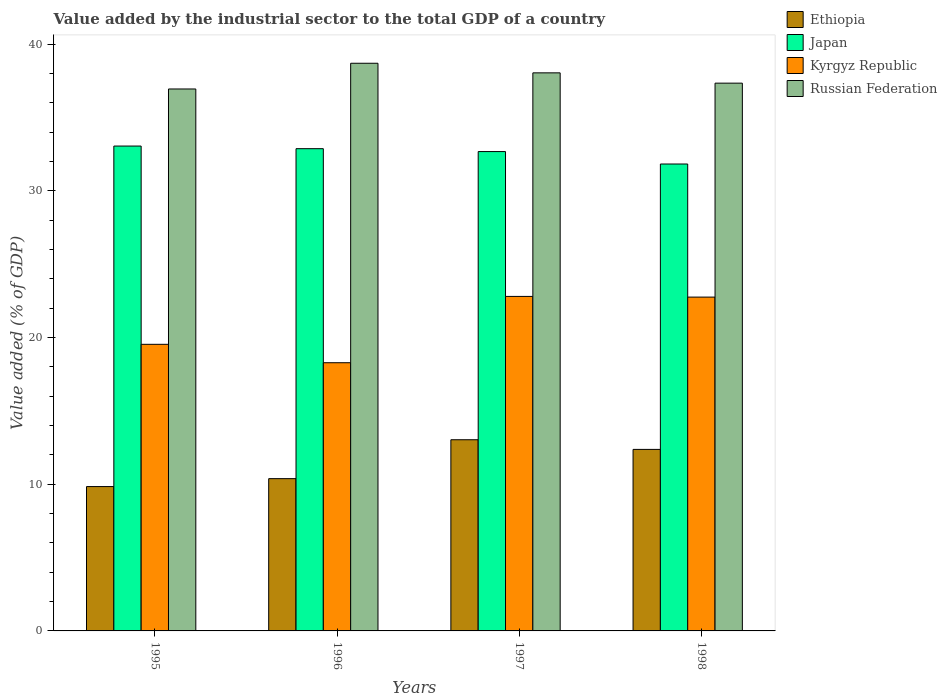How many groups of bars are there?
Ensure brevity in your answer.  4. Are the number of bars per tick equal to the number of legend labels?
Keep it short and to the point. Yes. How many bars are there on the 3rd tick from the left?
Your answer should be very brief. 4. How many bars are there on the 4th tick from the right?
Your answer should be compact. 4. What is the label of the 1st group of bars from the left?
Keep it short and to the point. 1995. In how many cases, is the number of bars for a given year not equal to the number of legend labels?
Give a very brief answer. 0. What is the value added by the industrial sector to the total GDP in Russian Federation in 1998?
Provide a succinct answer. 37.35. Across all years, what is the maximum value added by the industrial sector to the total GDP in Kyrgyz Republic?
Your answer should be very brief. 22.81. Across all years, what is the minimum value added by the industrial sector to the total GDP in Ethiopia?
Your answer should be very brief. 9.84. What is the total value added by the industrial sector to the total GDP in Japan in the graph?
Give a very brief answer. 130.48. What is the difference between the value added by the industrial sector to the total GDP in Kyrgyz Republic in 1995 and that in 1997?
Your response must be concise. -3.27. What is the difference between the value added by the industrial sector to the total GDP in Kyrgyz Republic in 1997 and the value added by the industrial sector to the total GDP in Japan in 1995?
Offer a terse response. -10.25. What is the average value added by the industrial sector to the total GDP in Ethiopia per year?
Provide a succinct answer. 11.41. In the year 1995, what is the difference between the value added by the industrial sector to the total GDP in Russian Federation and value added by the industrial sector to the total GDP in Ethiopia?
Ensure brevity in your answer.  27.11. What is the ratio of the value added by the industrial sector to the total GDP in Kyrgyz Republic in 1995 to that in 1997?
Provide a succinct answer. 0.86. Is the value added by the industrial sector to the total GDP in Russian Federation in 1996 less than that in 1998?
Give a very brief answer. No. What is the difference between the highest and the second highest value added by the industrial sector to the total GDP in Ethiopia?
Give a very brief answer. 0.66. What is the difference between the highest and the lowest value added by the industrial sector to the total GDP in Japan?
Give a very brief answer. 1.22. In how many years, is the value added by the industrial sector to the total GDP in Kyrgyz Republic greater than the average value added by the industrial sector to the total GDP in Kyrgyz Republic taken over all years?
Your response must be concise. 2. What does the 4th bar from the left in 1997 represents?
Your response must be concise. Russian Federation. What does the 1st bar from the right in 1995 represents?
Your answer should be very brief. Russian Federation. How many bars are there?
Keep it short and to the point. 16. How many years are there in the graph?
Provide a short and direct response. 4. Are the values on the major ticks of Y-axis written in scientific E-notation?
Make the answer very short. No. Where does the legend appear in the graph?
Your answer should be very brief. Top right. How many legend labels are there?
Keep it short and to the point. 4. What is the title of the graph?
Make the answer very short. Value added by the industrial sector to the total GDP of a country. What is the label or title of the X-axis?
Keep it short and to the point. Years. What is the label or title of the Y-axis?
Provide a short and direct response. Value added (% of GDP). What is the Value added (% of GDP) of Ethiopia in 1995?
Ensure brevity in your answer.  9.84. What is the Value added (% of GDP) of Japan in 1995?
Keep it short and to the point. 33.06. What is the Value added (% of GDP) in Kyrgyz Republic in 1995?
Offer a very short reply. 19.54. What is the Value added (% of GDP) of Russian Federation in 1995?
Offer a very short reply. 36.96. What is the Value added (% of GDP) of Ethiopia in 1996?
Give a very brief answer. 10.38. What is the Value added (% of GDP) in Japan in 1996?
Ensure brevity in your answer.  32.88. What is the Value added (% of GDP) of Kyrgyz Republic in 1996?
Your answer should be very brief. 18.29. What is the Value added (% of GDP) in Russian Federation in 1996?
Offer a very short reply. 38.71. What is the Value added (% of GDP) of Ethiopia in 1997?
Ensure brevity in your answer.  13.04. What is the Value added (% of GDP) in Japan in 1997?
Offer a very short reply. 32.69. What is the Value added (% of GDP) in Kyrgyz Republic in 1997?
Provide a short and direct response. 22.81. What is the Value added (% of GDP) of Russian Federation in 1997?
Offer a terse response. 38.06. What is the Value added (% of GDP) of Ethiopia in 1998?
Ensure brevity in your answer.  12.38. What is the Value added (% of GDP) in Japan in 1998?
Offer a terse response. 31.84. What is the Value added (% of GDP) of Kyrgyz Republic in 1998?
Make the answer very short. 22.76. What is the Value added (% of GDP) in Russian Federation in 1998?
Offer a very short reply. 37.35. Across all years, what is the maximum Value added (% of GDP) of Ethiopia?
Make the answer very short. 13.04. Across all years, what is the maximum Value added (% of GDP) in Japan?
Keep it short and to the point. 33.06. Across all years, what is the maximum Value added (% of GDP) of Kyrgyz Republic?
Make the answer very short. 22.81. Across all years, what is the maximum Value added (% of GDP) in Russian Federation?
Your answer should be very brief. 38.71. Across all years, what is the minimum Value added (% of GDP) of Ethiopia?
Your response must be concise. 9.84. Across all years, what is the minimum Value added (% of GDP) in Japan?
Offer a very short reply. 31.84. Across all years, what is the minimum Value added (% of GDP) of Kyrgyz Republic?
Provide a succinct answer. 18.29. Across all years, what is the minimum Value added (% of GDP) of Russian Federation?
Ensure brevity in your answer.  36.96. What is the total Value added (% of GDP) of Ethiopia in the graph?
Provide a short and direct response. 45.64. What is the total Value added (% of GDP) of Japan in the graph?
Your response must be concise. 130.48. What is the total Value added (% of GDP) of Kyrgyz Republic in the graph?
Your answer should be very brief. 83.41. What is the total Value added (% of GDP) in Russian Federation in the graph?
Offer a terse response. 151.07. What is the difference between the Value added (% of GDP) in Ethiopia in 1995 and that in 1996?
Provide a short and direct response. -0.54. What is the difference between the Value added (% of GDP) of Japan in 1995 and that in 1996?
Make the answer very short. 0.18. What is the difference between the Value added (% of GDP) of Kyrgyz Republic in 1995 and that in 1996?
Give a very brief answer. 1.25. What is the difference between the Value added (% of GDP) of Russian Federation in 1995 and that in 1996?
Make the answer very short. -1.75. What is the difference between the Value added (% of GDP) of Ethiopia in 1995 and that in 1997?
Make the answer very short. -3.19. What is the difference between the Value added (% of GDP) of Japan in 1995 and that in 1997?
Provide a short and direct response. 0.38. What is the difference between the Value added (% of GDP) of Kyrgyz Republic in 1995 and that in 1997?
Keep it short and to the point. -3.27. What is the difference between the Value added (% of GDP) in Russian Federation in 1995 and that in 1997?
Offer a terse response. -1.1. What is the difference between the Value added (% of GDP) in Ethiopia in 1995 and that in 1998?
Give a very brief answer. -2.54. What is the difference between the Value added (% of GDP) of Japan in 1995 and that in 1998?
Provide a succinct answer. 1.22. What is the difference between the Value added (% of GDP) in Kyrgyz Republic in 1995 and that in 1998?
Your response must be concise. -3.22. What is the difference between the Value added (% of GDP) in Russian Federation in 1995 and that in 1998?
Your answer should be very brief. -0.4. What is the difference between the Value added (% of GDP) in Ethiopia in 1996 and that in 1997?
Offer a very short reply. -2.65. What is the difference between the Value added (% of GDP) of Japan in 1996 and that in 1997?
Offer a very short reply. 0.2. What is the difference between the Value added (% of GDP) of Kyrgyz Republic in 1996 and that in 1997?
Offer a very short reply. -4.52. What is the difference between the Value added (% of GDP) in Russian Federation in 1996 and that in 1997?
Ensure brevity in your answer.  0.65. What is the difference between the Value added (% of GDP) in Ethiopia in 1996 and that in 1998?
Provide a succinct answer. -1.99. What is the difference between the Value added (% of GDP) in Japan in 1996 and that in 1998?
Offer a very short reply. 1.05. What is the difference between the Value added (% of GDP) of Kyrgyz Republic in 1996 and that in 1998?
Your response must be concise. -4.47. What is the difference between the Value added (% of GDP) in Russian Federation in 1996 and that in 1998?
Your answer should be compact. 1.36. What is the difference between the Value added (% of GDP) in Ethiopia in 1997 and that in 1998?
Provide a succinct answer. 0.66. What is the difference between the Value added (% of GDP) of Japan in 1997 and that in 1998?
Offer a terse response. 0.85. What is the difference between the Value added (% of GDP) in Kyrgyz Republic in 1997 and that in 1998?
Your response must be concise. 0.05. What is the difference between the Value added (% of GDP) in Russian Federation in 1997 and that in 1998?
Give a very brief answer. 0.7. What is the difference between the Value added (% of GDP) in Ethiopia in 1995 and the Value added (% of GDP) in Japan in 1996?
Offer a terse response. -23.04. What is the difference between the Value added (% of GDP) of Ethiopia in 1995 and the Value added (% of GDP) of Kyrgyz Republic in 1996?
Give a very brief answer. -8.45. What is the difference between the Value added (% of GDP) in Ethiopia in 1995 and the Value added (% of GDP) in Russian Federation in 1996?
Make the answer very short. -28.87. What is the difference between the Value added (% of GDP) in Japan in 1995 and the Value added (% of GDP) in Kyrgyz Republic in 1996?
Your answer should be very brief. 14.77. What is the difference between the Value added (% of GDP) of Japan in 1995 and the Value added (% of GDP) of Russian Federation in 1996?
Your answer should be compact. -5.65. What is the difference between the Value added (% of GDP) in Kyrgyz Republic in 1995 and the Value added (% of GDP) in Russian Federation in 1996?
Offer a terse response. -19.17. What is the difference between the Value added (% of GDP) in Ethiopia in 1995 and the Value added (% of GDP) in Japan in 1997?
Ensure brevity in your answer.  -22.84. What is the difference between the Value added (% of GDP) in Ethiopia in 1995 and the Value added (% of GDP) in Kyrgyz Republic in 1997?
Ensure brevity in your answer.  -12.97. What is the difference between the Value added (% of GDP) of Ethiopia in 1995 and the Value added (% of GDP) of Russian Federation in 1997?
Provide a short and direct response. -28.21. What is the difference between the Value added (% of GDP) in Japan in 1995 and the Value added (% of GDP) in Kyrgyz Republic in 1997?
Your answer should be compact. 10.25. What is the difference between the Value added (% of GDP) of Japan in 1995 and the Value added (% of GDP) of Russian Federation in 1997?
Your answer should be compact. -4.99. What is the difference between the Value added (% of GDP) of Kyrgyz Republic in 1995 and the Value added (% of GDP) of Russian Federation in 1997?
Keep it short and to the point. -18.51. What is the difference between the Value added (% of GDP) in Ethiopia in 1995 and the Value added (% of GDP) in Japan in 1998?
Provide a short and direct response. -22. What is the difference between the Value added (% of GDP) of Ethiopia in 1995 and the Value added (% of GDP) of Kyrgyz Republic in 1998?
Offer a very short reply. -12.92. What is the difference between the Value added (% of GDP) in Ethiopia in 1995 and the Value added (% of GDP) in Russian Federation in 1998?
Your answer should be compact. -27.51. What is the difference between the Value added (% of GDP) of Japan in 1995 and the Value added (% of GDP) of Kyrgyz Republic in 1998?
Your response must be concise. 10.3. What is the difference between the Value added (% of GDP) of Japan in 1995 and the Value added (% of GDP) of Russian Federation in 1998?
Make the answer very short. -4.29. What is the difference between the Value added (% of GDP) of Kyrgyz Republic in 1995 and the Value added (% of GDP) of Russian Federation in 1998?
Provide a succinct answer. -17.81. What is the difference between the Value added (% of GDP) of Ethiopia in 1996 and the Value added (% of GDP) of Japan in 1997?
Your answer should be compact. -22.3. What is the difference between the Value added (% of GDP) in Ethiopia in 1996 and the Value added (% of GDP) in Kyrgyz Republic in 1997?
Offer a very short reply. -12.43. What is the difference between the Value added (% of GDP) of Ethiopia in 1996 and the Value added (% of GDP) of Russian Federation in 1997?
Give a very brief answer. -27.67. What is the difference between the Value added (% of GDP) in Japan in 1996 and the Value added (% of GDP) in Kyrgyz Republic in 1997?
Ensure brevity in your answer.  10.07. What is the difference between the Value added (% of GDP) of Japan in 1996 and the Value added (% of GDP) of Russian Federation in 1997?
Your answer should be compact. -5.17. What is the difference between the Value added (% of GDP) of Kyrgyz Republic in 1996 and the Value added (% of GDP) of Russian Federation in 1997?
Ensure brevity in your answer.  -19.77. What is the difference between the Value added (% of GDP) in Ethiopia in 1996 and the Value added (% of GDP) in Japan in 1998?
Your answer should be compact. -21.46. What is the difference between the Value added (% of GDP) of Ethiopia in 1996 and the Value added (% of GDP) of Kyrgyz Republic in 1998?
Your answer should be compact. -12.38. What is the difference between the Value added (% of GDP) of Ethiopia in 1996 and the Value added (% of GDP) of Russian Federation in 1998?
Make the answer very short. -26.97. What is the difference between the Value added (% of GDP) in Japan in 1996 and the Value added (% of GDP) in Kyrgyz Republic in 1998?
Offer a terse response. 10.12. What is the difference between the Value added (% of GDP) in Japan in 1996 and the Value added (% of GDP) in Russian Federation in 1998?
Make the answer very short. -4.47. What is the difference between the Value added (% of GDP) of Kyrgyz Republic in 1996 and the Value added (% of GDP) of Russian Federation in 1998?
Keep it short and to the point. -19.06. What is the difference between the Value added (% of GDP) in Ethiopia in 1997 and the Value added (% of GDP) in Japan in 1998?
Keep it short and to the point. -18.8. What is the difference between the Value added (% of GDP) in Ethiopia in 1997 and the Value added (% of GDP) in Kyrgyz Republic in 1998?
Make the answer very short. -9.73. What is the difference between the Value added (% of GDP) in Ethiopia in 1997 and the Value added (% of GDP) in Russian Federation in 1998?
Make the answer very short. -24.32. What is the difference between the Value added (% of GDP) in Japan in 1997 and the Value added (% of GDP) in Kyrgyz Republic in 1998?
Offer a terse response. 9.92. What is the difference between the Value added (% of GDP) of Japan in 1997 and the Value added (% of GDP) of Russian Federation in 1998?
Your answer should be very brief. -4.67. What is the difference between the Value added (% of GDP) of Kyrgyz Republic in 1997 and the Value added (% of GDP) of Russian Federation in 1998?
Your answer should be very brief. -14.54. What is the average Value added (% of GDP) in Ethiopia per year?
Ensure brevity in your answer.  11.41. What is the average Value added (% of GDP) in Japan per year?
Keep it short and to the point. 32.62. What is the average Value added (% of GDP) in Kyrgyz Republic per year?
Provide a succinct answer. 20.85. What is the average Value added (% of GDP) of Russian Federation per year?
Provide a succinct answer. 37.77. In the year 1995, what is the difference between the Value added (% of GDP) of Ethiopia and Value added (% of GDP) of Japan?
Your answer should be very brief. -23.22. In the year 1995, what is the difference between the Value added (% of GDP) in Ethiopia and Value added (% of GDP) in Russian Federation?
Your answer should be compact. -27.11. In the year 1995, what is the difference between the Value added (% of GDP) in Japan and Value added (% of GDP) in Kyrgyz Republic?
Keep it short and to the point. 13.52. In the year 1995, what is the difference between the Value added (% of GDP) of Japan and Value added (% of GDP) of Russian Federation?
Make the answer very short. -3.89. In the year 1995, what is the difference between the Value added (% of GDP) of Kyrgyz Republic and Value added (% of GDP) of Russian Federation?
Give a very brief answer. -17.41. In the year 1996, what is the difference between the Value added (% of GDP) of Ethiopia and Value added (% of GDP) of Japan?
Provide a succinct answer. -22.5. In the year 1996, what is the difference between the Value added (% of GDP) in Ethiopia and Value added (% of GDP) in Kyrgyz Republic?
Your response must be concise. -7.91. In the year 1996, what is the difference between the Value added (% of GDP) in Ethiopia and Value added (% of GDP) in Russian Federation?
Your response must be concise. -28.33. In the year 1996, what is the difference between the Value added (% of GDP) of Japan and Value added (% of GDP) of Kyrgyz Republic?
Offer a terse response. 14.6. In the year 1996, what is the difference between the Value added (% of GDP) in Japan and Value added (% of GDP) in Russian Federation?
Your answer should be very brief. -5.82. In the year 1996, what is the difference between the Value added (% of GDP) in Kyrgyz Republic and Value added (% of GDP) in Russian Federation?
Your answer should be very brief. -20.42. In the year 1997, what is the difference between the Value added (% of GDP) of Ethiopia and Value added (% of GDP) of Japan?
Give a very brief answer. -19.65. In the year 1997, what is the difference between the Value added (% of GDP) in Ethiopia and Value added (% of GDP) in Kyrgyz Republic?
Your response must be concise. -9.77. In the year 1997, what is the difference between the Value added (% of GDP) of Ethiopia and Value added (% of GDP) of Russian Federation?
Provide a succinct answer. -25.02. In the year 1997, what is the difference between the Value added (% of GDP) of Japan and Value added (% of GDP) of Kyrgyz Republic?
Provide a succinct answer. 9.88. In the year 1997, what is the difference between the Value added (% of GDP) of Japan and Value added (% of GDP) of Russian Federation?
Give a very brief answer. -5.37. In the year 1997, what is the difference between the Value added (% of GDP) of Kyrgyz Republic and Value added (% of GDP) of Russian Federation?
Provide a short and direct response. -15.25. In the year 1998, what is the difference between the Value added (% of GDP) in Ethiopia and Value added (% of GDP) in Japan?
Your answer should be very brief. -19.46. In the year 1998, what is the difference between the Value added (% of GDP) of Ethiopia and Value added (% of GDP) of Kyrgyz Republic?
Your answer should be compact. -10.39. In the year 1998, what is the difference between the Value added (% of GDP) of Ethiopia and Value added (% of GDP) of Russian Federation?
Offer a terse response. -24.98. In the year 1998, what is the difference between the Value added (% of GDP) in Japan and Value added (% of GDP) in Kyrgyz Republic?
Offer a terse response. 9.08. In the year 1998, what is the difference between the Value added (% of GDP) in Japan and Value added (% of GDP) in Russian Federation?
Give a very brief answer. -5.51. In the year 1998, what is the difference between the Value added (% of GDP) in Kyrgyz Republic and Value added (% of GDP) in Russian Federation?
Your response must be concise. -14.59. What is the ratio of the Value added (% of GDP) of Ethiopia in 1995 to that in 1996?
Keep it short and to the point. 0.95. What is the ratio of the Value added (% of GDP) in Japan in 1995 to that in 1996?
Offer a very short reply. 1.01. What is the ratio of the Value added (% of GDP) of Kyrgyz Republic in 1995 to that in 1996?
Offer a very short reply. 1.07. What is the ratio of the Value added (% of GDP) of Russian Federation in 1995 to that in 1996?
Your answer should be very brief. 0.95. What is the ratio of the Value added (% of GDP) in Ethiopia in 1995 to that in 1997?
Offer a very short reply. 0.76. What is the ratio of the Value added (% of GDP) in Japan in 1995 to that in 1997?
Ensure brevity in your answer.  1.01. What is the ratio of the Value added (% of GDP) of Kyrgyz Republic in 1995 to that in 1997?
Give a very brief answer. 0.86. What is the ratio of the Value added (% of GDP) of Russian Federation in 1995 to that in 1997?
Offer a very short reply. 0.97. What is the ratio of the Value added (% of GDP) of Ethiopia in 1995 to that in 1998?
Make the answer very short. 0.8. What is the ratio of the Value added (% of GDP) of Japan in 1995 to that in 1998?
Ensure brevity in your answer.  1.04. What is the ratio of the Value added (% of GDP) of Kyrgyz Republic in 1995 to that in 1998?
Give a very brief answer. 0.86. What is the ratio of the Value added (% of GDP) of Russian Federation in 1995 to that in 1998?
Provide a short and direct response. 0.99. What is the ratio of the Value added (% of GDP) in Ethiopia in 1996 to that in 1997?
Your answer should be very brief. 0.8. What is the ratio of the Value added (% of GDP) of Japan in 1996 to that in 1997?
Your answer should be very brief. 1.01. What is the ratio of the Value added (% of GDP) of Kyrgyz Republic in 1996 to that in 1997?
Keep it short and to the point. 0.8. What is the ratio of the Value added (% of GDP) in Russian Federation in 1996 to that in 1997?
Your answer should be compact. 1.02. What is the ratio of the Value added (% of GDP) of Ethiopia in 1996 to that in 1998?
Offer a terse response. 0.84. What is the ratio of the Value added (% of GDP) of Japan in 1996 to that in 1998?
Your response must be concise. 1.03. What is the ratio of the Value added (% of GDP) of Kyrgyz Republic in 1996 to that in 1998?
Provide a short and direct response. 0.8. What is the ratio of the Value added (% of GDP) of Russian Federation in 1996 to that in 1998?
Offer a very short reply. 1.04. What is the ratio of the Value added (% of GDP) of Ethiopia in 1997 to that in 1998?
Make the answer very short. 1.05. What is the ratio of the Value added (% of GDP) of Japan in 1997 to that in 1998?
Offer a very short reply. 1.03. What is the ratio of the Value added (% of GDP) of Kyrgyz Republic in 1997 to that in 1998?
Offer a very short reply. 1. What is the ratio of the Value added (% of GDP) of Russian Federation in 1997 to that in 1998?
Offer a terse response. 1.02. What is the difference between the highest and the second highest Value added (% of GDP) of Ethiopia?
Ensure brevity in your answer.  0.66. What is the difference between the highest and the second highest Value added (% of GDP) in Japan?
Keep it short and to the point. 0.18. What is the difference between the highest and the second highest Value added (% of GDP) of Kyrgyz Republic?
Make the answer very short. 0.05. What is the difference between the highest and the second highest Value added (% of GDP) of Russian Federation?
Offer a terse response. 0.65. What is the difference between the highest and the lowest Value added (% of GDP) of Ethiopia?
Your response must be concise. 3.19. What is the difference between the highest and the lowest Value added (% of GDP) in Japan?
Give a very brief answer. 1.22. What is the difference between the highest and the lowest Value added (% of GDP) of Kyrgyz Republic?
Your response must be concise. 4.52. What is the difference between the highest and the lowest Value added (% of GDP) in Russian Federation?
Make the answer very short. 1.75. 